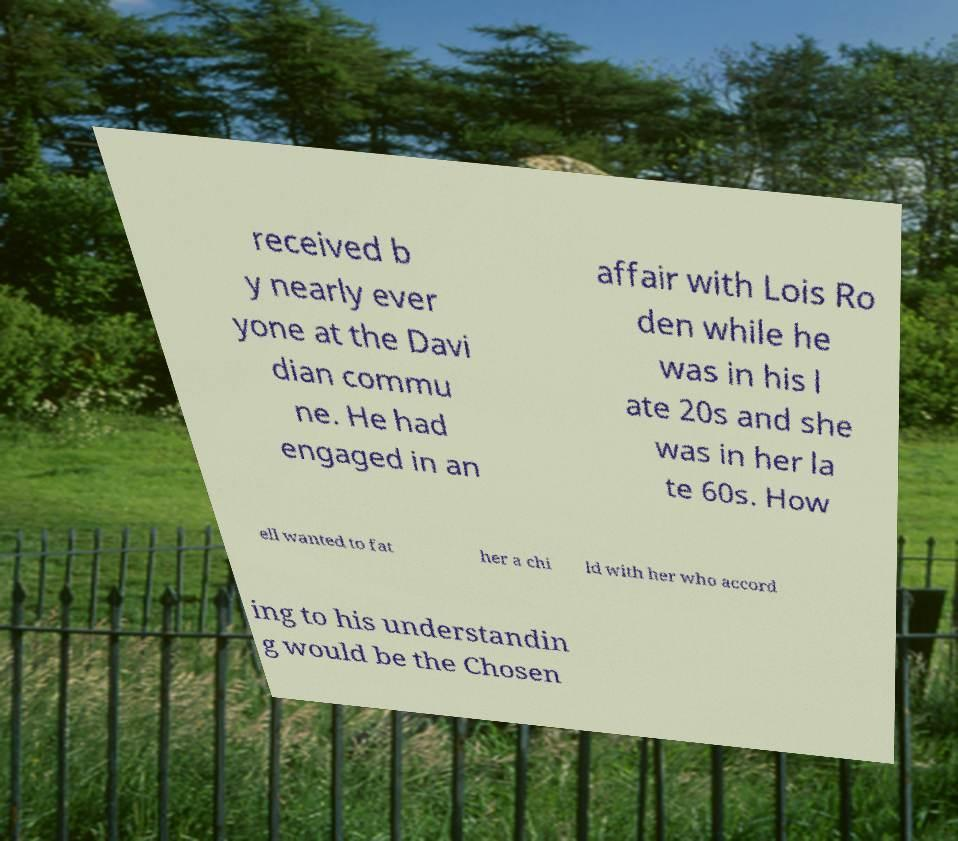Could you extract and type out the text from this image? received b y nearly ever yone at the Davi dian commu ne. He had engaged in an affair with Lois Ro den while he was in his l ate 20s and she was in her la te 60s. How ell wanted to fat her a chi ld with her who accord ing to his understandin g would be the Chosen 